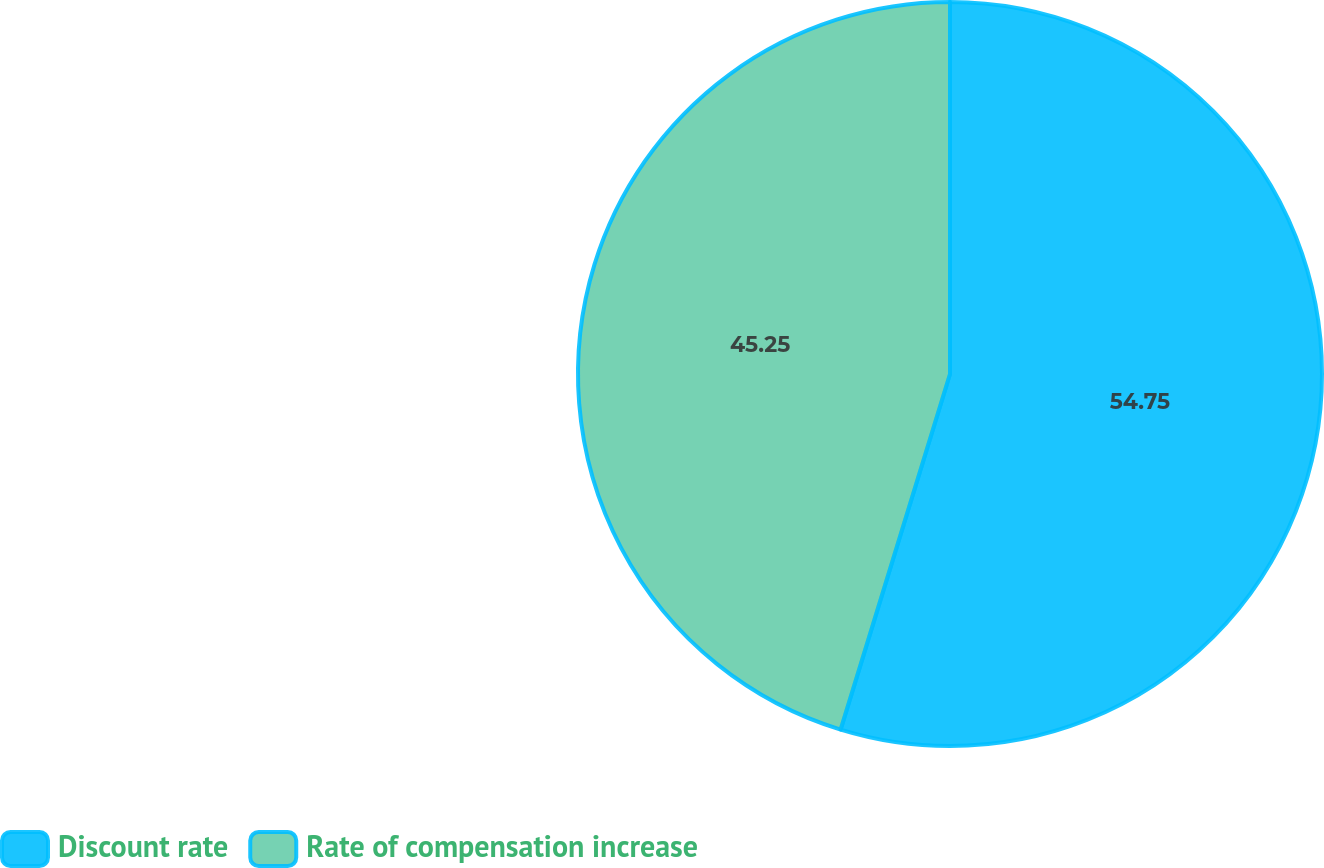Convert chart to OTSL. <chart><loc_0><loc_0><loc_500><loc_500><pie_chart><fcel>Discount rate<fcel>Rate of compensation increase<nl><fcel>54.75%<fcel>45.25%<nl></chart> 